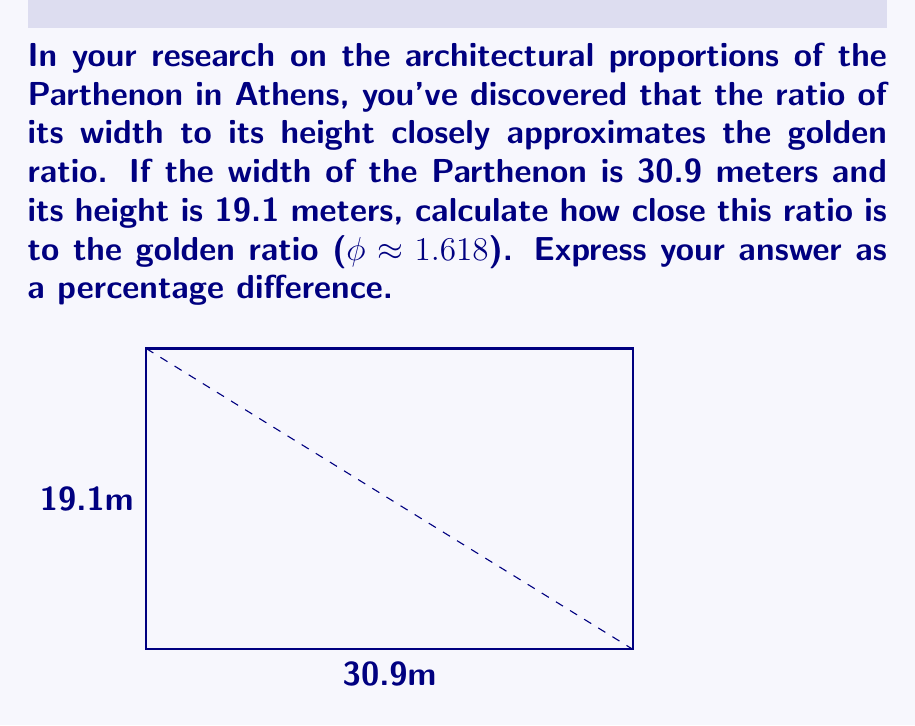Provide a solution to this math problem. Let's approach this step-by-step:

1) First, let's calculate the ratio of the Parthenon's width to its height:
   $\text{Parthenon ratio} = \frac{\text{width}}{\text{height}} = \frac{30.9}{19.1} \approx 1.6178$

2) The golden ratio (φ) is approximately 1.618.

3) To calculate the percentage difference, we use the formula:
   $\text{Percentage difference} = |\frac{\text{Observed value} - \text{Expected value}}{\text{Expected value}}| \times 100\%$

4) Plugging in our values:
   $\text{Percentage difference} = |\frac{1.6178 - 1.618}{1.618}| \times 100\%$

5) Simplifying:
   $= |\frac{-0.0002}{1.618}| \times 100\%$
   $\approx 0.0124\%$

Therefore, the ratio of the Parthenon's width to its height differs from the golden ratio by approximately 0.0124%.
Answer: 0.0124% 